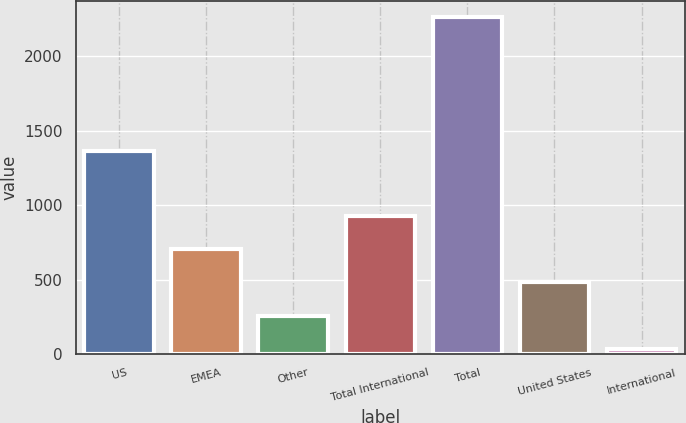<chart> <loc_0><loc_0><loc_500><loc_500><bar_chart><fcel>US<fcel>EMEA<fcel>Other<fcel>Total International<fcel>Total<fcel>United States<fcel>International<nl><fcel>1361.8<fcel>703.67<fcel>259.29<fcel>925.86<fcel>2259<fcel>481.48<fcel>37.1<nl></chart> 